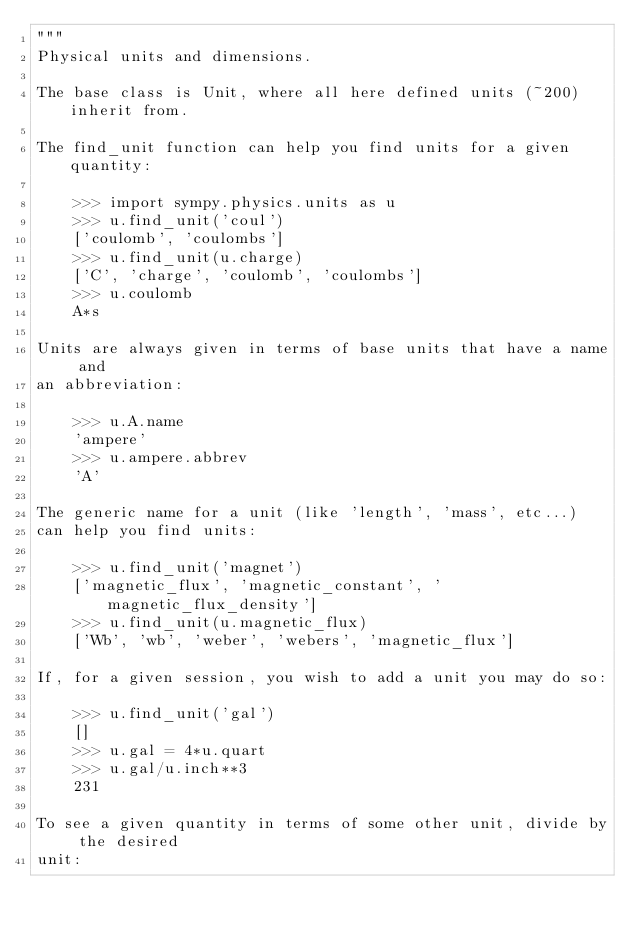Convert code to text. <code><loc_0><loc_0><loc_500><loc_500><_Python_>"""
Physical units and dimensions.

The base class is Unit, where all here defined units (~200) inherit from.

The find_unit function can help you find units for a given quantity:

    >>> import sympy.physics.units as u
    >>> u.find_unit('coul')
    ['coulomb', 'coulombs']
    >>> u.find_unit(u.charge)
    ['C', 'charge', 'coulomb', 'coulombs']
    >>> u.coulomb
    A*s

Units are always given in terms of base units that have a name and
an abbreviation:

    >>> u.A.name
    'ampere'
    >>> u.ampere.abbrev
    'A'

The generic name for a unit (like 'length', 'mass', etc...)
can help you find units:

    >>> u.find_unit('magnet')
    ['magnetic_flux', 'magnetic_constant', 'magnetic_flux_density']
    >>> u.find_unit(u.magnetic_flux)
    ['Wb', 'wb', 'weber', 'webers', 'magnetic_flux']

If, for a given session, you wish to add a unit you may do so:

    >>> u.find_unit('gal')
    []
    >>> u.gal = 4*u.quart
    >>> u.gal/u.inch**3
    231

To see a given quantity in terms of some other unit, divide by the desired
unit:
</code> 